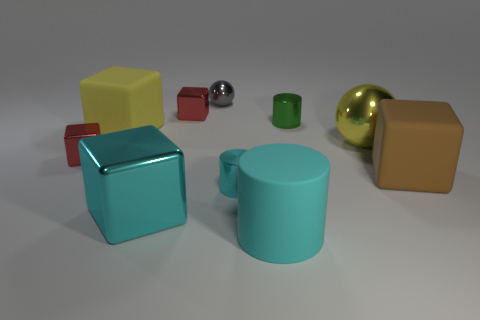What time of day does the lighting in this image suggest? The lighting in the image is soft and diffused, with minimal shadows, suggesting an overcast day or an environment with ambient lighting that doesn't mimic a natural setting, such as an indoor studio with controlled light sources. 